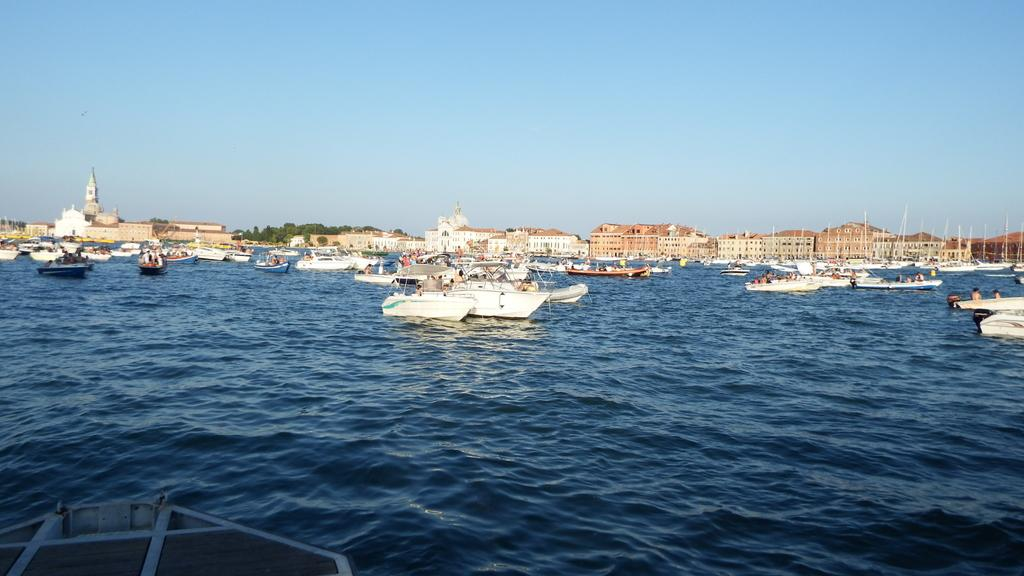What type of location is depicted in the image? There is a beach in the image. What types of watercraft can be seen in the image? There are boats and ships in the image. What structures are present in the image? There are buildings in the image. What type of vegetation is visible in the image? There are trees in the image. What type of man-made objects can be seen in the image? There are poles in the image. What type of attention is the brother receiving from the zinc in the image? There is no brother or zinc present in the image. 